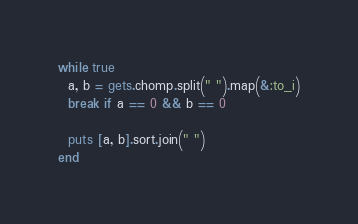<code> <loc_0><loc_0><loc_500><loc_500><_Ruby_>while true
  a, b = gets.chomp.split(" ").map(&:to_i)
  break if a == 0 && b == 0
  
  puts [a, b].sort.join(" ")
end
</code> 